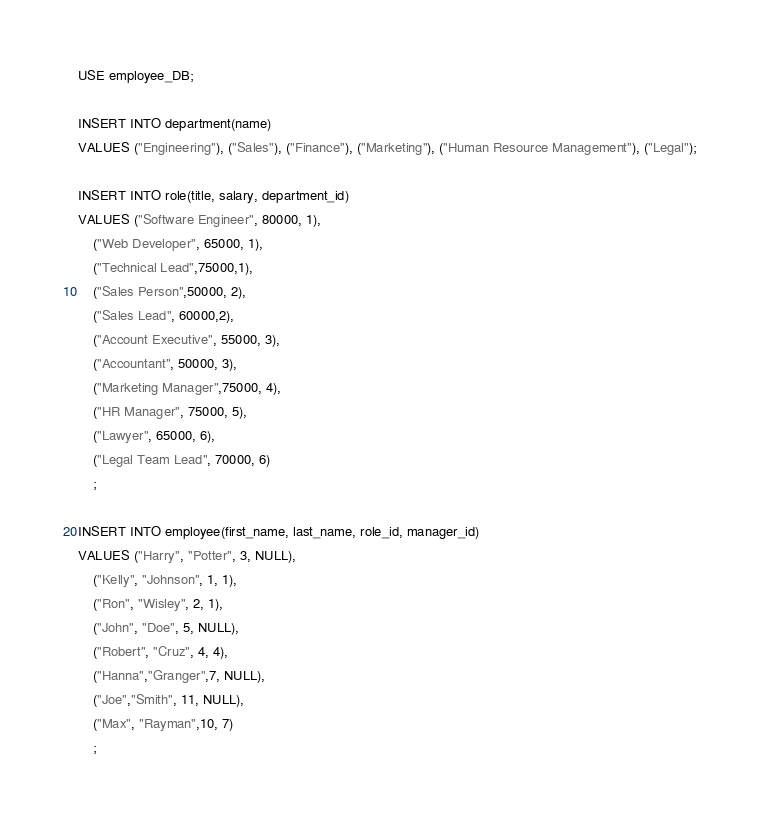<code> <loc_0><loc_0><loc_500><loc_500><_SQL_>USE employee_DB;

INSERT INTO department(name)
VALUES ("Engineering"), ("Sales"), ("Finance"), ("Marketing"), ("Human Resource Management"), ("Legal");

INSERT INTO role(title, salary, department_id)
VALUES ("Software Engineer", 80000, 1), 
	("Web Developer", 65000, 1), 
	("Technical Lead",75000,1),
	("Sales Person",50000, 2),
	("Sales Lead", 60000,2),
	("Account Executive", 55000, 3),
	("Accountant", 50000, 3),
	("Marketing Manager",75000, 4),
	("HR Manager", 75000, 5),
	("Lawyer", 65000, 6),
	("Legal Team Lead", 70000, 6)
    ;
    
INSERT INTO employee(first_name, last_name, role_id, manager_id)
VALUES ("Harry", "Potter", 3, NULL),
	("Kelly", "Johnson", 1, 1),
	("Ron", "Wisley", 2, 1),
	("John", "Doe", 5, NULL),
	("Robert", "Cruz", 4, 4),
	("Hanna","Granger",7, NULL),
	("Joe","Smith", 11, NULL),
	("Max", "Rayman",10, 7)
    ;

</code> 